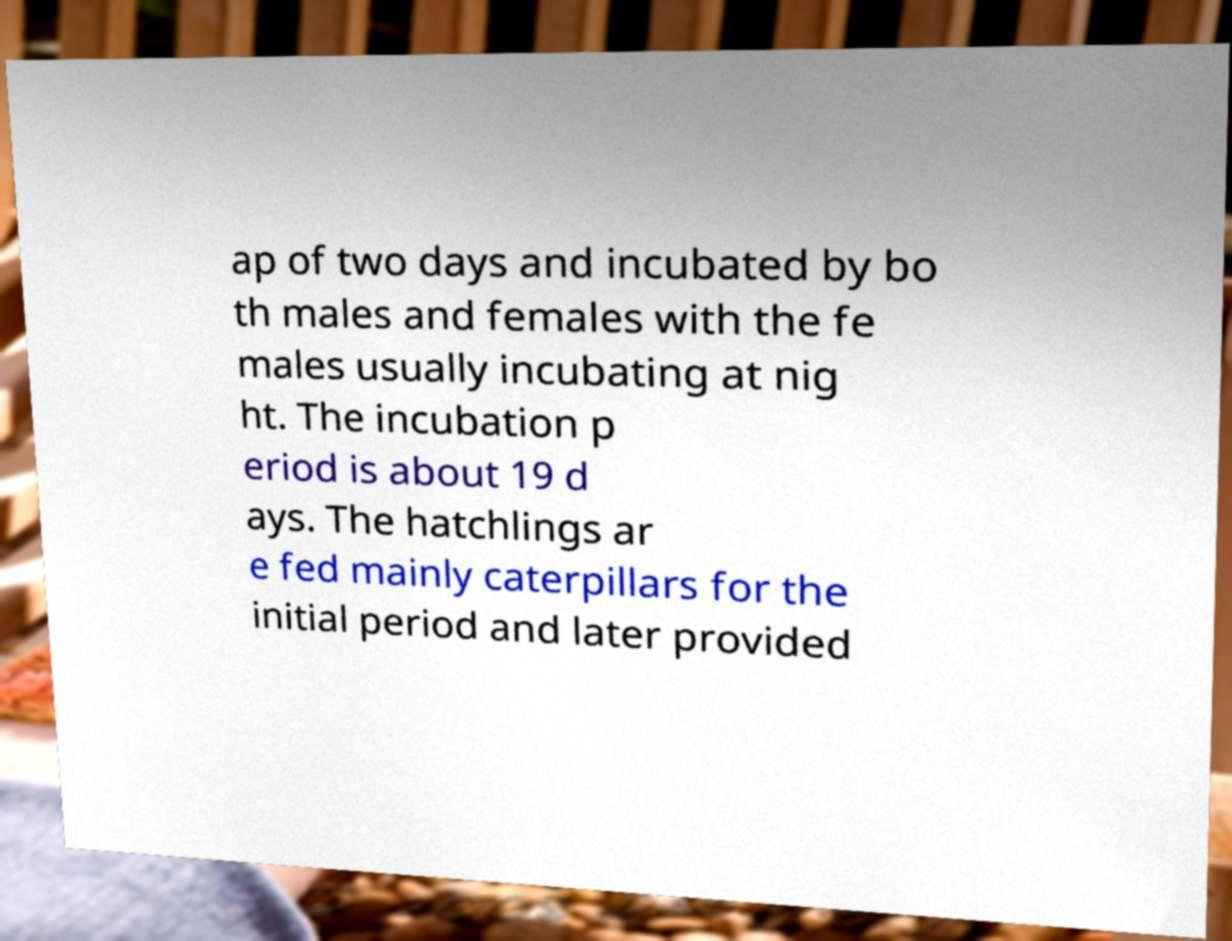Please read and relay the text visible in this image. What does it say? ap of two days and incubated by bo th males and females with the fe males usually incubating at nig ht. The incubation p eriod is about 19 d ays. The hatchlings ar e fed mainly caterpillars for the initial period and later provided 